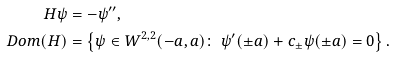<formula> <loc_0><loc_0><loc_500><loc_500>H \psi & = - \psi ^ { \prime \prime } , \\ \ D o m ( H ) & = \left \{ \psi \in W ^ { 2 , 2 } ( - a , a ) \colon \ \psi ^ { \prime } ( \pm a ) + c _ { \pm } \psi ( \pm a ) = 0 \right \} .</formula> 